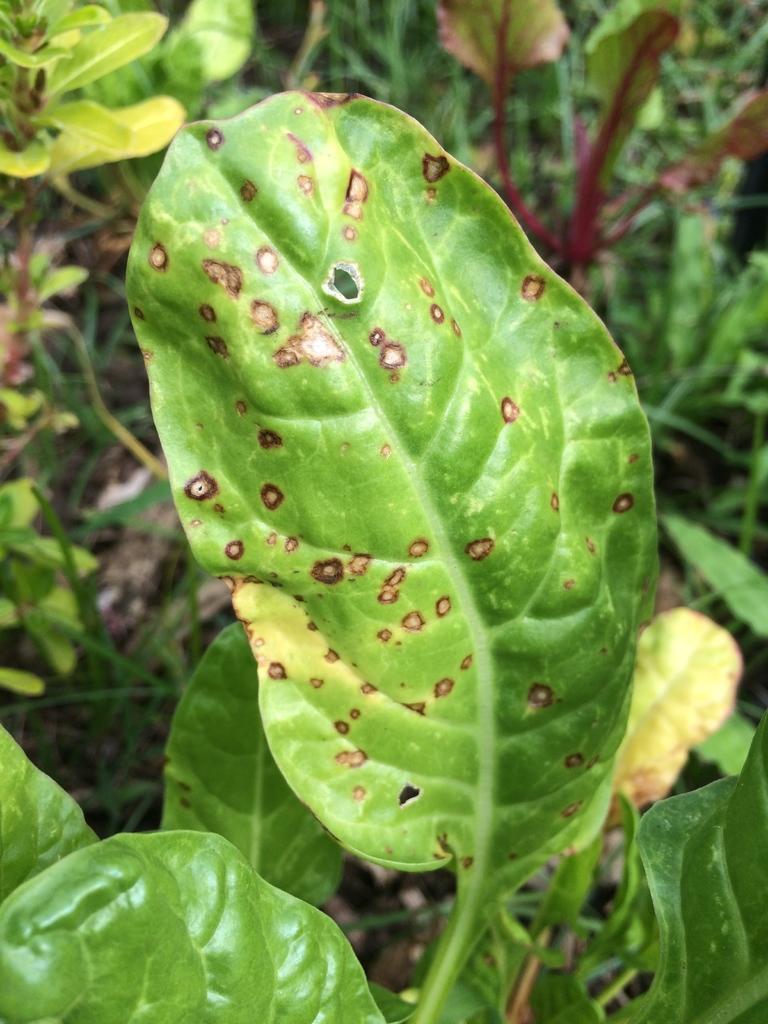How would you summarize this image in a sentence or two? In this picture we can see few plants and leaves. 